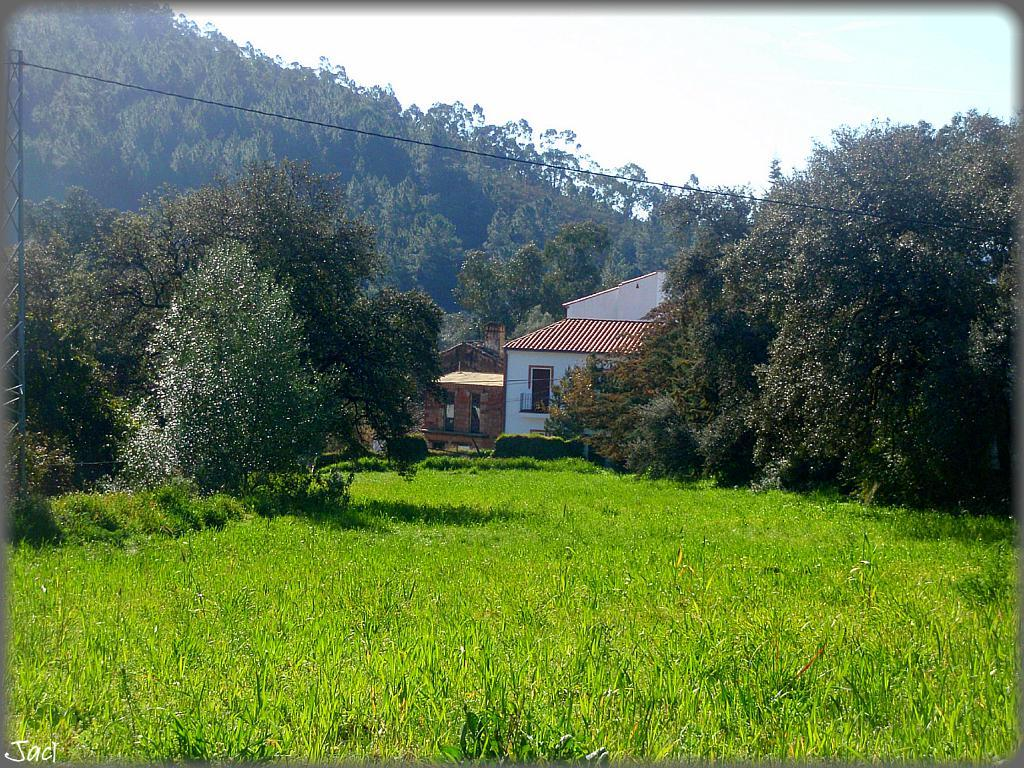What type of vegetation is present in the image? There are trees and grass in the image. What type of structure can be seen in the image? There is a house in the image. How many nets are visible in the image? There are no nets present in the image. Are there any giants visible in the image? There are no giants present in the image. 